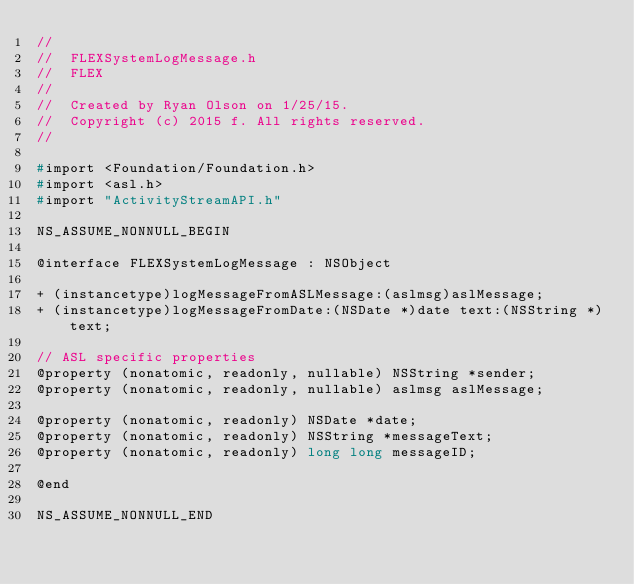Convert code to text. <code><loc_0><loc_0><loc_500><loc_500><_C_>//
//  FLEXSystemLogMessage.h
//  FLEX
//
//  Created by Ryan Olson on 1/25/15.
//  Copyright (c) 2015 f. All rights reserved.
//

#import <Foundation/Foundation.h>
#import <asl.h>
#import "ActivityStreamAPI.h"

NS_ASSUME_NONNULL_BEGIN

@interface FLEXSystemLogMessage : NSObject

+ (instancetype)logMessageFromASLMessage:(aslmsg)aslMessage;
+ (instancetype)logMessageFromDate:(NSDate *)date text:(NSString *)text;

// ASL specific properties
@property (nonatomic, readonly, nullable) NSString *sender;
@property (nonatomic, readonly, nullable) aslmsg aslMessage;

@property (nonatomic, readonly) NSDate *date;
@property (nonatomic, readonly) NSString *messageText;
@property (nonatomic, readonly) long long messageID;

@end

NS_ASSUME_NONNULL_END
</code> 